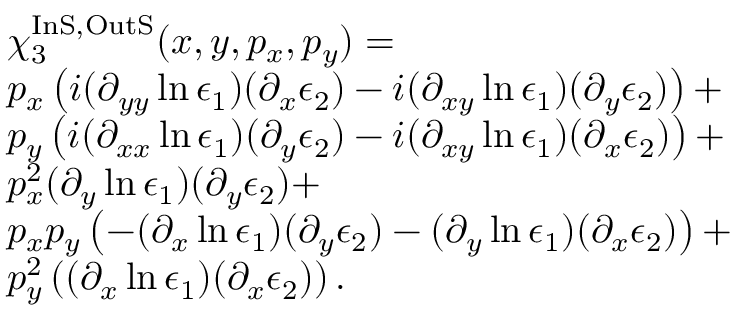<formula> <loc_0><loc_0><loc_500><loc_500>\begin{array} { r l } & { \chi _ { 3 } ^ { I n S , O u t S } ( x , y , p _ { x } , p _ { y } ) = } \\ & { p _ { x } \left ( i ( \partial _ { y y } \ln \epsilon _ { 1 } ) ( \partial _ { x } \epsilon _ { 2 } ) - i ( \partial _ { x y } \ln \epsilon _ { 1 } ) ( \partial _ { y } \epsilon _ { 2 } ) \right ) + } \\ & { p _ { y } \left ( i ( \partial _ { x x } \ln \epsilon _ { 1 } ) ( \partial _ { y } \epsilon _ { 2 } ) - i ( \partial _ { x y } \ln \epsilon _ { 1 } ) ( \partial _ { x } \epsilon _ { 2 } ) \right ) + } \\ & { p _ { x } ^ { 2 } ( \partial _ { y } \ln \epsilon _ { 1 } ) ( \partial _ { y } \epsilon _ { 2 } ) + } \\ & { p _ { x } p _ { y } \left ( - ( \partial _ { x } \ln \epsilon _ { 1 } ) ( \partial _ { y } \epsilon _ { 2 } ) - ( \partial _ { y } \ln \epsilon _ { 1 } ) ( \partial _ { x } \epsilon _ { 2 } ) \right ) + } \\ & { p _ { y } ^ { 2 } \left ( ( \partial _ { x } \ln \epsilon _ { 1 } ) ( \partial _ { x } \epsilon _ { 2 } ) \right ) . } \end{array}</formula> 